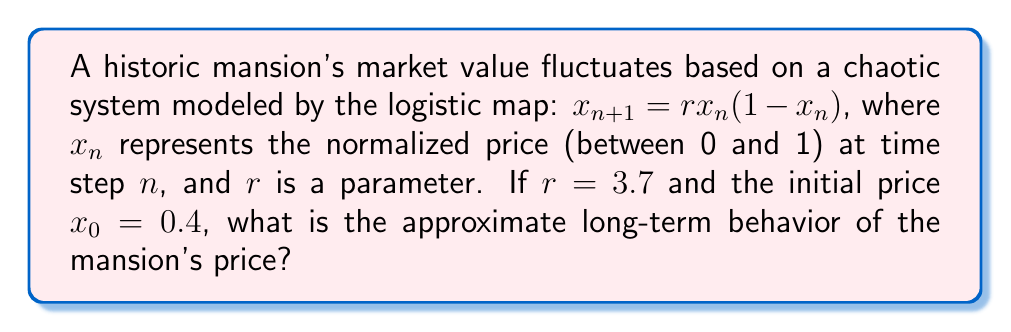Teach me how to tackle this problem. To analyze the long-term behavior of the mansion's price, we need to iterate the logistic map and observe its attractor:

1) First, let's calculate the first few iterations:
   $x_1 = 3.7 \cdot 0.4 \cdot (1-0.4) = 0.888$
   $x_2 = 3.7 \cdot 0.888 \cdot (1-0.888) \approx 0.3684$
   $x_3 = 3.7 \cdot 0.3684 \cdot (1-0.3684) \approx 0.8614$

2) Continuing this process for many iterations, we observe that the values do not settle on a single fixed point or a simple periodic cycle.

3) For $r = 3.7$, the logistic map exhibits chaotic behavior. In the long term, the values will bounce around unpredictably within a certain range.

4) To visualize this, we can create a bifurcation diagram:

   [asy]
   import graph;
   size(200,150);
   
   real f(real x, real r) {
     return r*x*(1-x);
   }
   
   for(real r = 2.5; r <= 4; r += 0.005) {
     real x = 0.5;
     for(int i = 0; i < 100; ++i) {
       x = f(x,r);
     }
     for(int i = 0; i < 100; ++i) {
       x = f(x,r);
       dot((r,x), blue+0.2);
     }
   }
   
   xaxis("r", xmin=2.5, xmax=4, arrow=Arrow);
   yaxis("x", ymin=0, ymax=1, arrow=Arrow);
   
   draw((3.7,0)--(3.7,1), red);
   [/asy]

5) The red line in the diagram represents $r = 3.7$. We can see that for this value, the system has a chaotic attractor, meaning the price will fluctuate within a specific range but in an unpredictable manner.

6) This range can be approximated by iterating the map many times and observing the minimum and maximum values. After many iterations, we find that the values typically fall between approximately 0.3 and 0.9.

Therefore, in the long term, the mansion's normalized price will exhibit chaotic fluctuations, typically ranging between about 0.3 and 0.9.
Answer: Chaotic fluctuations between $\approx 0.3$ and $\approx 0.9$ 